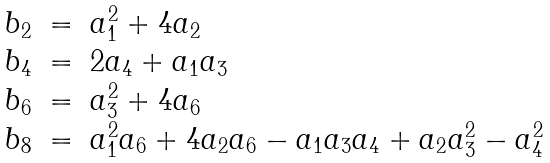Convert formula to latex. <formula><loc_0><loc_0><loc_500><loc_500>\begin{array} { r c l } b _ { 2 } & = & a _ { 1 } ^ { 2 } + 4 a _ { 2 } \\ b _ { 4 } & = & 2 a _ { 4 } + a _ { 1 } a _ { 3 } \\ b _ { 6 } & = & a _ { 3 } ^ { 2 } + 4 a _ { 6 } \\ b _ { 8 } & = & a _ { 1 } ^ { 2 } a _ { 6 } + 4 a _ { 2 } a _ { 6 } - a _ { 1 } a _ { 3 } a _ { 4 } + a _ { 2 } a _ { 3 } ^ { 2 } - a _ { 4 } ^ { 2 } \end{array}</formula> 